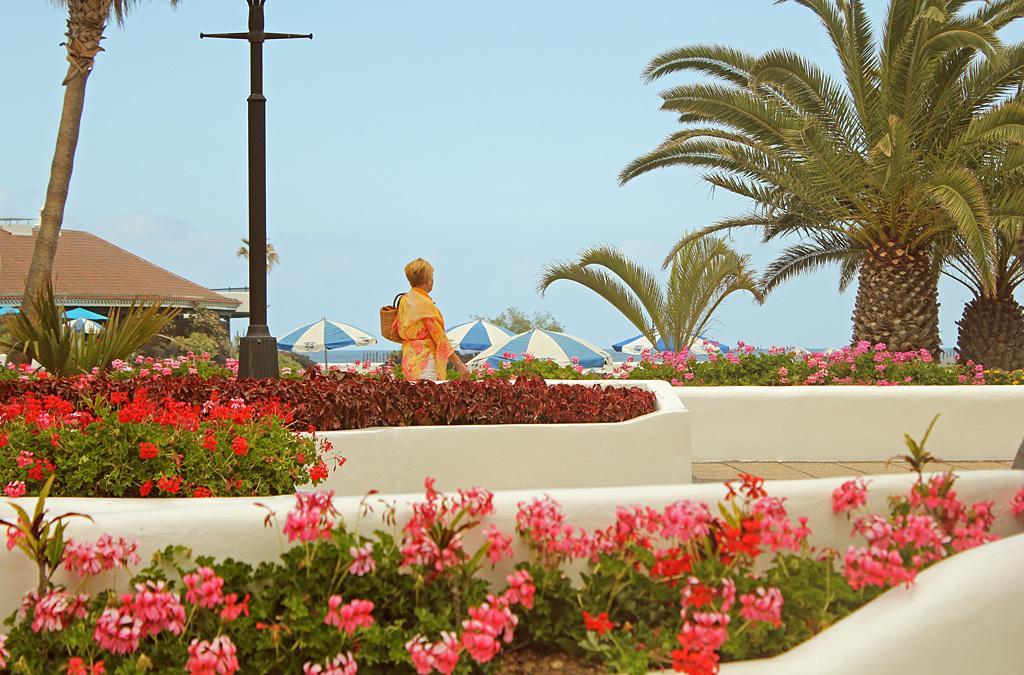In one or two sentences, can you explain what this image depicts? In this image we can see a woman standing beside a fence. We can also see a group of plants with flowers, some trees and a pole. On the backside we can see some outdoor umbrellas, a house with a roof, a water body and the sky which looks cloudy. 